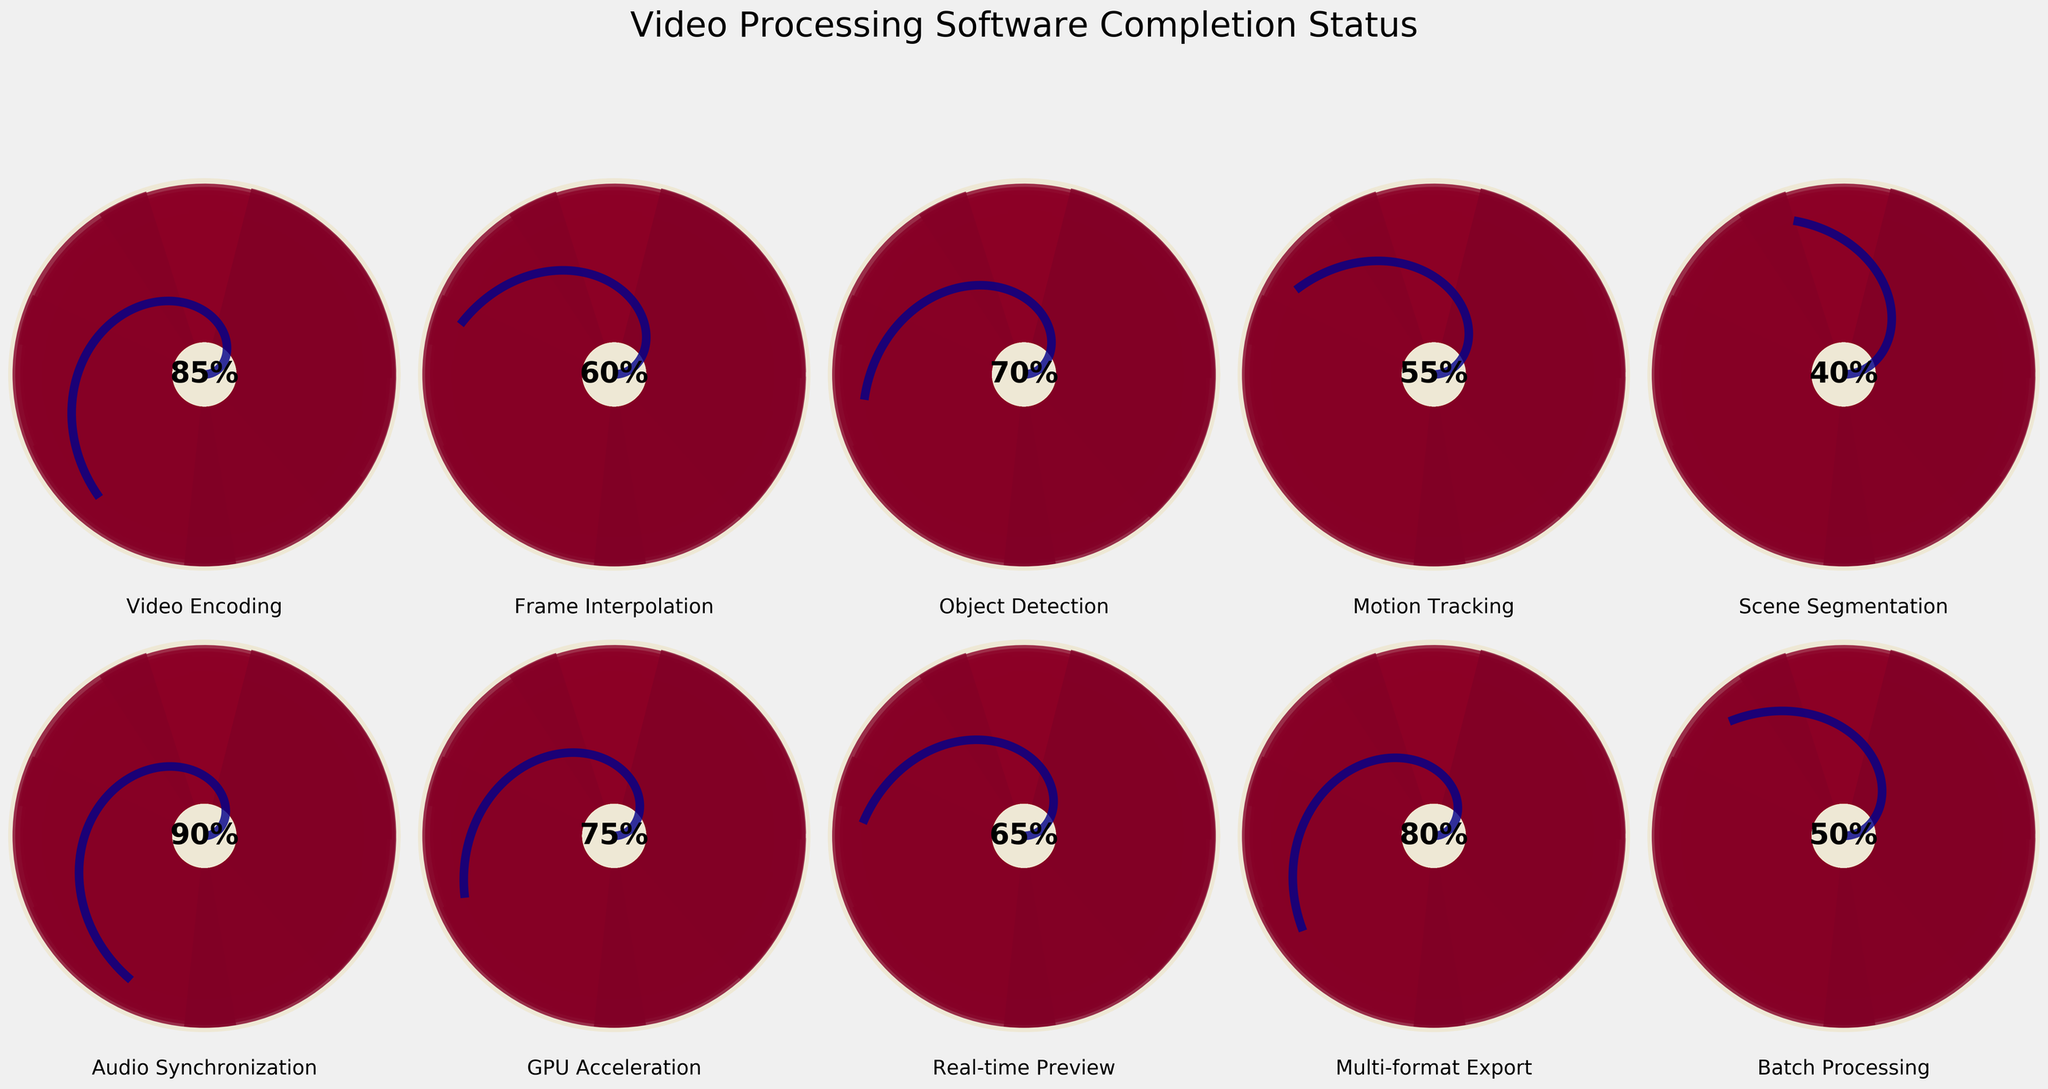What is the title of the figure? The title is located at the top of the figure and displays the overall theme of the plotted charts.
Answer: Video Processing Software Completion Status What feature has the highest percentage of completion? The highest percentage can be identified by locating the chart with the highest percentage value displayed in the center.
Answer: Audio Synchronization How many features have a completion percentage greater than 70? To find this, identify the charts with percentages above 70 and count them. Audio Synchronization (90), Video Encoding (85), GPU Acceleration (75), and Multi-format Export (80) are all greater than 70.
Answer: 4 What is the average completion percentage of all features? Sum up all the percentages and divide by the total number of features. (85 + 60 + 70 + 55 + 40 + 90 + 75 + 65 + 80 + 50) / 10 = 67
Answer: 67 Which feature has a higher completion percentage: Motion Tracking or Batch Processing? Compare the two percentages: Motion Tracking (55) and Batch Processing (50).
Answer: Motion Tracking What is the median completion percentage among all the features? To find the median, list all the completion percentages in ascending order, then find the middle value. The sorted list is (40, 50, 55, 60, 65, 70, 75, 80, 85, 90). The middle values are 65 and 70, and their average is (65 + 70) / 2 = 67.5.
Answer: 67.5 Which feature has the smallest completion percentage, and what is it? Find the chart with the lowest percentage displayed.
Answer: Scene Segmentation, 40 How does Real-time Preview's completion percentage compare to the average completion percentage? Calculate the average (67) and compare it to Real-time Preview's percentage (65).
Answer: Slightly less than average What is the total completion percentage if you combine Frame Interpolation and Object Detection? Add the two percentages together: 60 (Frame Interpolation) + 70 (Object Detection) = 130.
Answer: 130 Which feature has a completion percentage that is approximately the same as the overall average? The average is 67, and the closest percentage is Real-time Preview (65).
Answer: Real-time Preview 